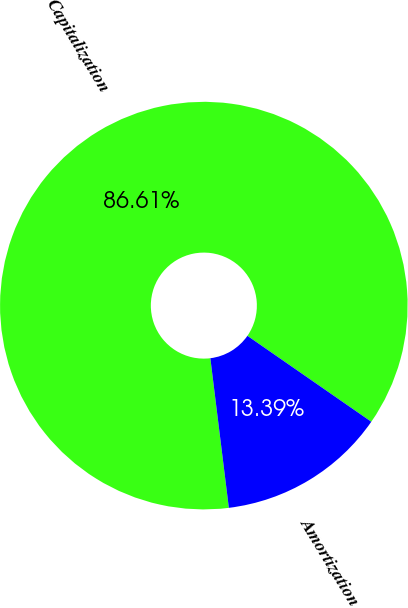Convert chart to OTSL. <chart><loc_0><loc_0><loc_500><loc_500><pie_chart><fcel>Capitalization<fcel>Amortization<nl><fcel>86.61%<fcel>13.39%<nl></chart> 